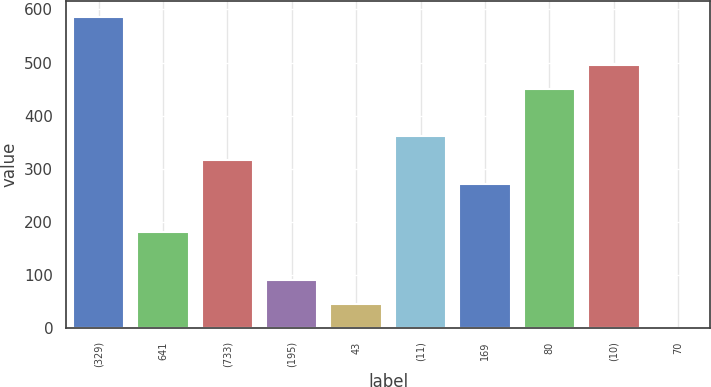Convert chart to OTSL. <chart><loc_0><loc_0><loc_500><loc_500><bar_chart><fcel>(329)<fcel>641<fcel>(733)<fcel>(195)<fcel>43<fcel>(11)<fcel>169<fcel>80<fcel>(10)<fcel>70<nl><fcel>586<fcel>181<fcel>316<fcel>91<fcel>46<fcel>361<fcel>271<fcel>451<fcel>496<fcel>1<nl></chart> 